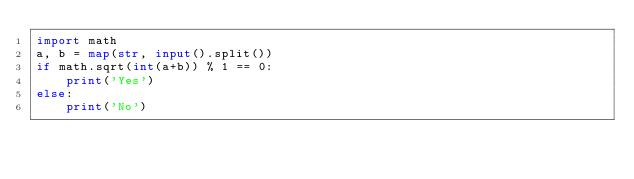Convert code to text. <code><loc_0><loc_0><loc_500><loc_500><_Python_>import math
a, b = map(str, input().split())
if math.sqrt(int(a+b)) % 1 == 0:
    print('Yes')
else:
    print('No')</code> 